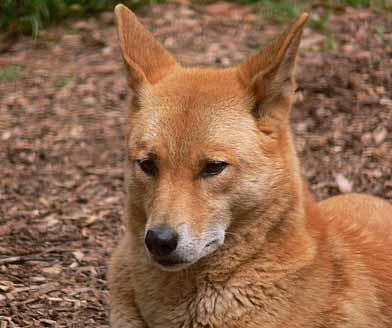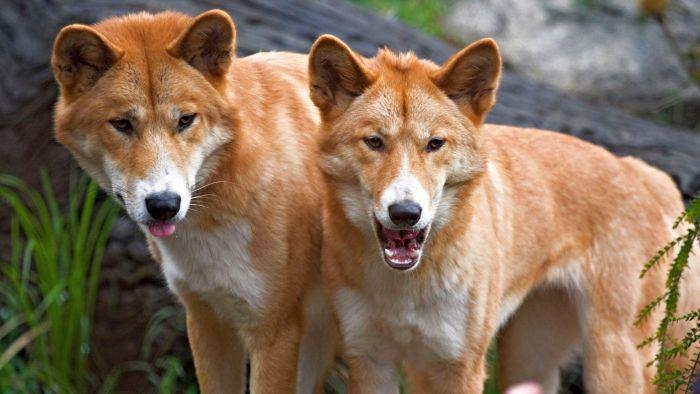The first image is the image on the left, the second image is the image on the right. Analyze the images presented: Is the assertion "At least one image includes a dog standing with head facing the camera." valid? Answer yes or no. Yes. 